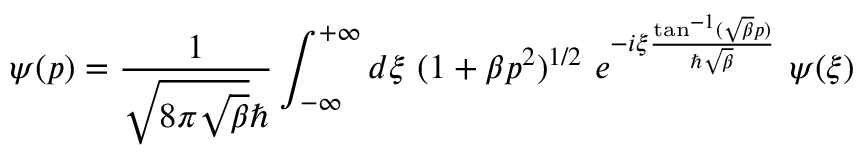Convert formula to latex. <formula><loc_0><loc_0><loc_500><loc_500>\psi ( p ) = \frac { 1 } { \sqrt { 8 \pi \sqrt { \beta } } } \int _ { - \infty } ^ { + \infty } d { \xi ( 1 + \beta p ^ { 2 } ) ^ { 1 / 2 e ^ { - i { \xi } \frac { \tan ^ { - 1 } ( \sqrt { \beta } p ) } { \hbar { \sqrt } { \beta } } \psi ( { \xi } )</formula> 